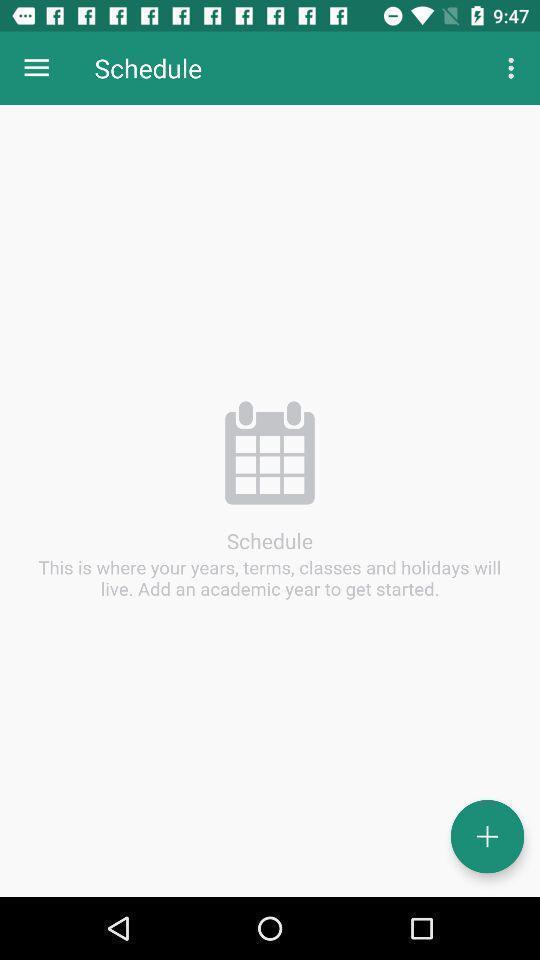What details can you identify in this image? Screen displaying the schedule page. 